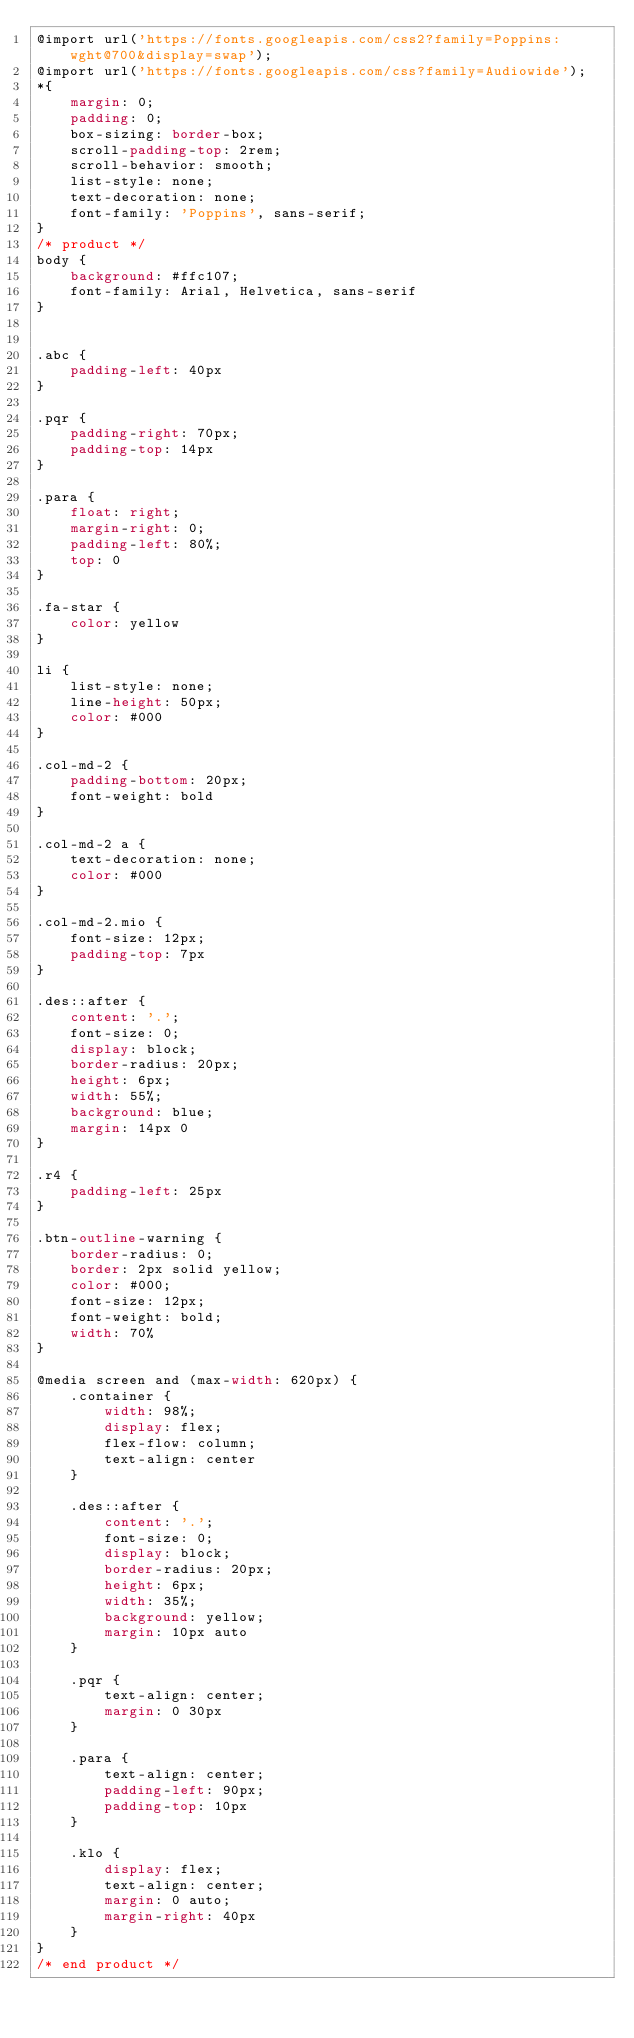Convert code to text. <code><loc_0><loc_0><loc_500><loc_500><_CSS_>@import url('https://fonts.googleapis.com/css2?family=Poppins:wght@700&display=swap');
@import url('https://fonts.googleapis.com/css?family=Audiowide');
*{
    margin: 0;
    padding: 0;
    box-sizing: border-box;
    scroll-padding-top: 2rem;
    scroll-behavior: smooth;
    list-style: none;
    text-decoration: none;
    font-family: 'Poppins', sans-serif;
}
/* product */
body {
    background: #ffc107;
    font-family: Arial, Helvetica, sans-serif
}


.abc {
    padding-left: 40px
}

.pqr {
    padding-right: 70px;
    padding-top: 14px
}

.para {
    float: right;
    margin-right: 0;
    padding-left: 80%;
    top: 0
}

.fa-star {
    color: yellow
}

li {
    list-style: none;
    line-height: 50px;
    color: #000
}

.col-md-2 {
    padding-bottom: 20px;
    font-weight: bold
}

.col-md-2 a {
    text-decoration: none;
    color: #000
}

.col-md-2.mio {
    font-size: 12px;
    padding-top: 7px
}

.des::after {
    content: '.';
    font-size: 0;
    display: block;
    border-radius: 20px;
    height: 6px;
    width: 55%;
    background: blue;
    margin: 14px 0
}

.r4 {
    padding-left: 25px
}

.btn-outline-warning {
    border-radius: 0;
    border: 2px solid yellow;
    color: #000;
    font-size: 12px;
    font-weight: bold;
    width: 70%
}

@media screen and (max-width: 620px) {
    .container {
        width: 98%;
        display: flex;
        flex-flow: column;
        text-align: center
    }

    .des::after {
        content: '.';
        font-size: 0;
        display: block;
        border-radius: 20px;
        height: 6px;
        width: 35%;
        background: yellow;
        margin: 10px auto
    }

    .pqr {
        text-align: center;
        margin: 0 30px
    }

    .para {
        text-align: center;
        padding-left: 90px;
        padding-top: 10px
    }

    .klo {
        display: flex;
        text-align: center;
        margin: 0 auto;
        margin-right: 40px
    }
}
/* end product */
</code> 